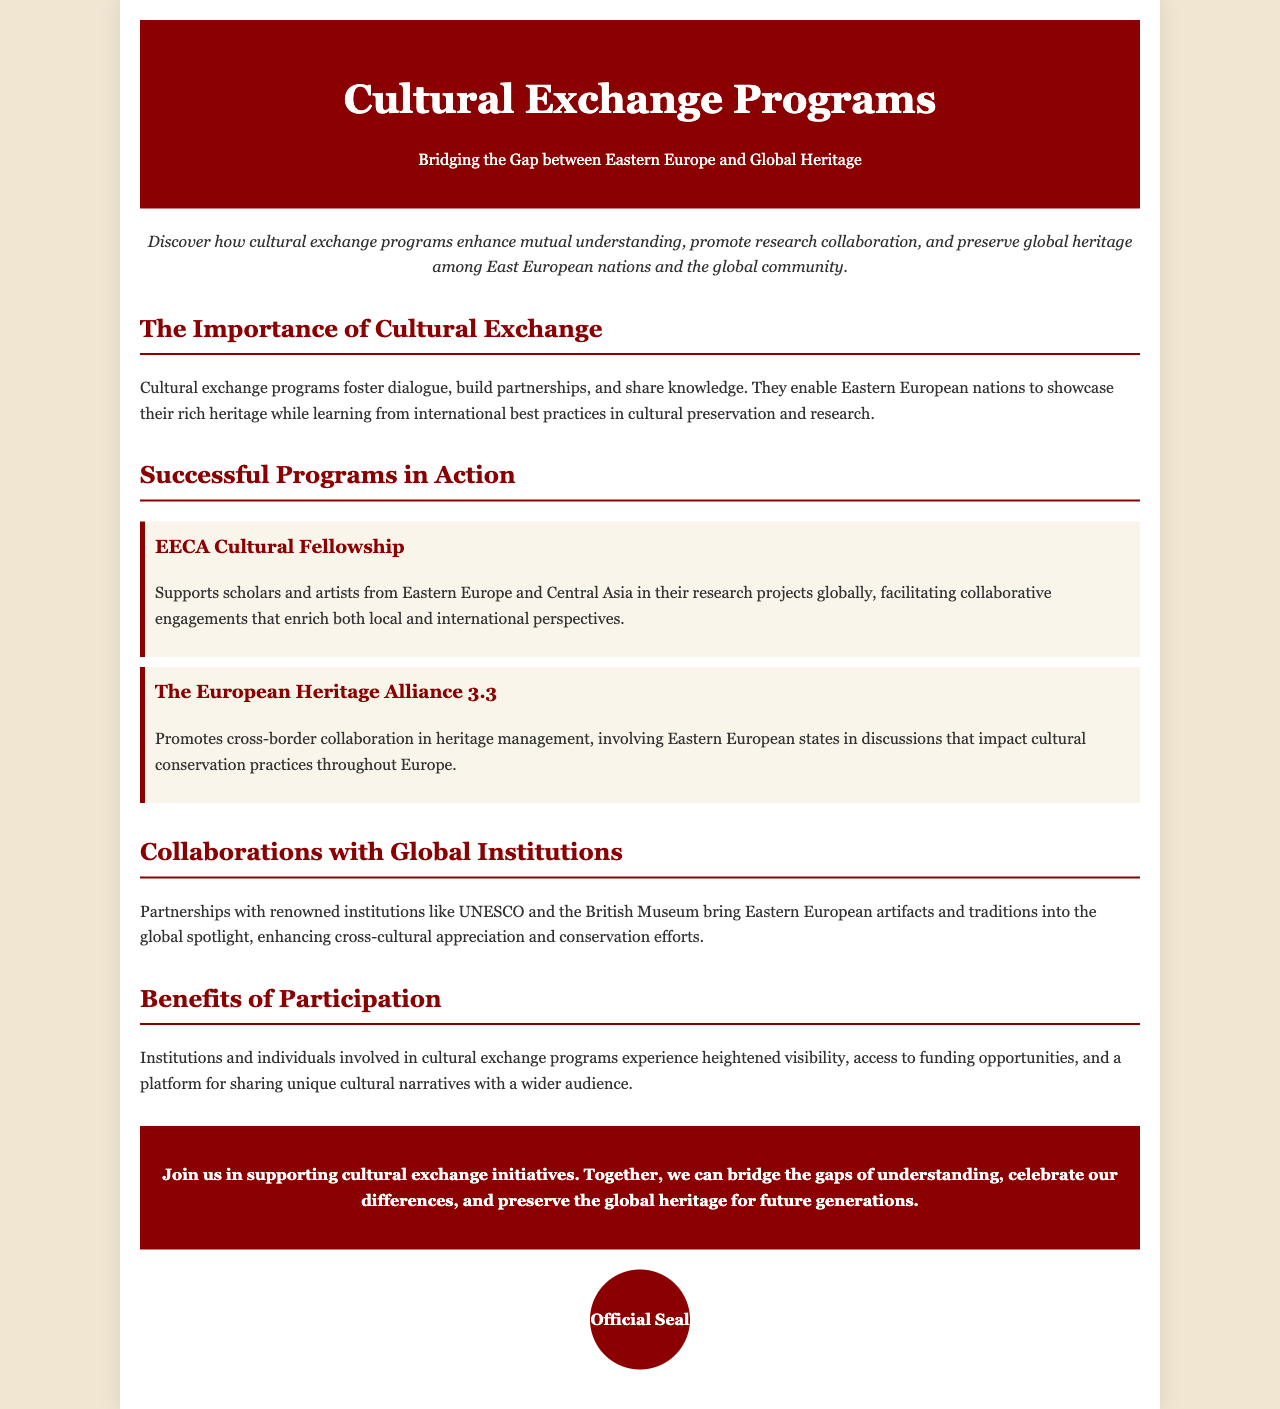What is the title of the brochure? The title is stated prominently at the top of the document, referring to the specific theme of the content.
Answer: Cultural Exchange Programs: Bridging the Gap between Eastern Europe and Global Heritage What is the significance of cultural exchange programs? The document provides details about the impact of cultural exchange programs outlined in the importance section.
Answer: Foster dialogue, build partnerships, and share knowledge What support does the EECA Cultural Fellowship provide? The description of the program specifies who it supports and the purpose of its initiatives in the context of cultural exchange.
Answer: Supports scholars and artists from Eastern Europe and Central Asia Which organization collaborates in heritage management? The document names a specific alliance that promotes collaboration regarding heritage, as mentioned under successful programs.
Answer: The European Heritage Alliance 3.3 What is a benefit of participating in cultural exchange programs? The document highlights key advantages of involvement in these initiatives within the benefits section.
Answer: Heightened visibility How do collaboration with global institutions enhance appreciation? The reasoning requires understanding both the partnerships and their outcomes mentioned in the collaborations section.
Answer: Brings Eastern European artifacts and traditions into the global spotlight What is the color of the header background? The document visually specifies this design element, which helps in identifying key sections.
Answer: Dark red How are the programs structured in the brochure? The document layout consists of sections and programs, organized distinctly to present information clearly.
Answer: Themed sections and program highlights 